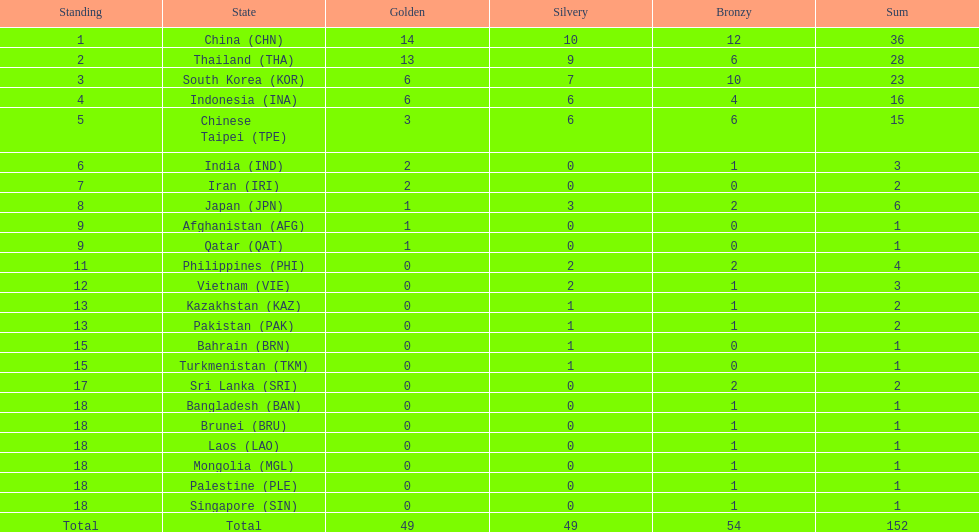How many total gold medal have been given? 49. 